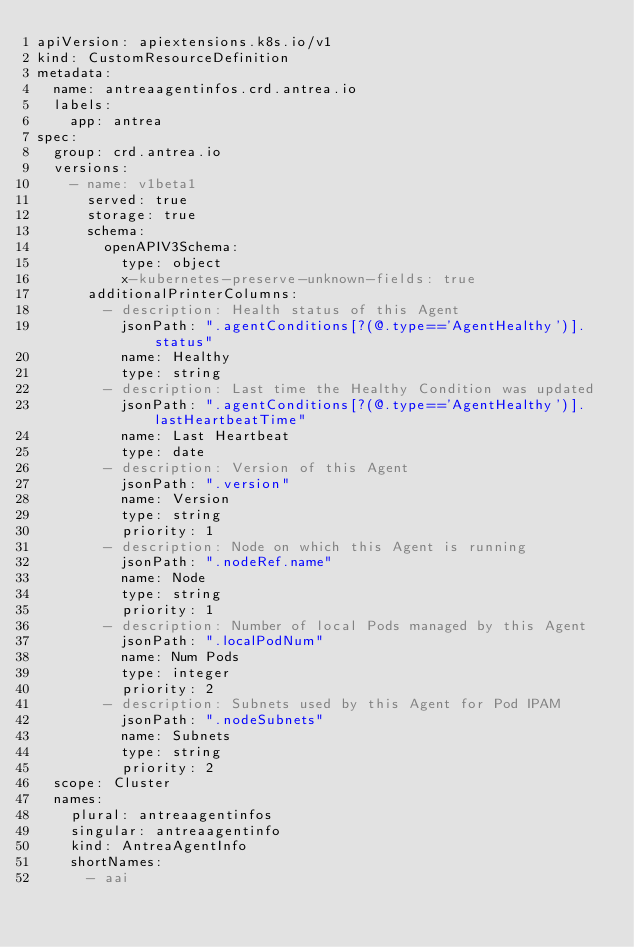Convert code to text. <code><loc_0><loc_0><loc_500><loc_500><_YAML_>apiVersion: apiextensions.k8s.io/v1
kind: CustomResourceDefinition
metadata:
  name: antreaagentinfos.crd.antrea.io
  labels:
    app: antrea
spec:
  group: crd.antrea.io
  versions:
    - name: v1beta1
      served: true
      storage: true
      schema:
        openAPIV3Schema:
          type: object
          x-kubernetes-preserve-unknown-fields: true
      additionalPrinterColumns:
        - description: Health status of this Agent
          jsonPath: ".agentConditions[?(@.type=='AgentHealthy')].status"
          name: Healthy
          type: string
        - description: Last time the Healthy Condition was updated
          jsonPath: ".agentConditions[?(@.type=='AgentHealthy')].lastHeartbeatTime"
          name: Last Heartbeat
          type: date
        - description: Version of this Agent
          jsonPath: ".version"
          name: Version
          type: string
          priority: 1
        - description: Node on which this Agent is running
          jsonPath: ".nodeRef.name"
          name: Node
          type: string
          priority: 1
        - description: Number of local Pods managed by this Agent
          jsonPath: ".localPodNum"
          name: Num Pods
          type: integer
          priority: 2
        - description: Subnets used by this Agent for Pod IPAM
          jsonPath: ".nodeSubnets"
          name: Subnets
          type: string
          priority: 2
  scope: Cluster
  names:
    plural: antreaagentinfos
    singular: antreaagentinfo
    kind: AntreaAgentInfo
    shortNames:
      - aai
</code> 